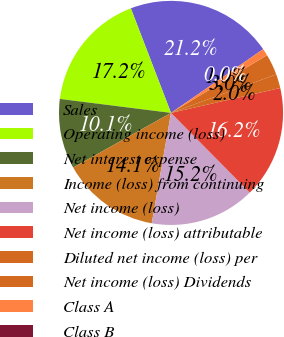<chart> <loc_0><loc_0><loc_500><loc_500><pie_chart><fcel>Sales<fcel>Operating income (loss)<fcel>Net interest expense<fcel>Income (loss) from continuing<fcel>Net income (loss)<fcel>Net income (loss) attributable<fcel>Diluted net income (loss) per<fcel>Net income (loss) Dividends<fcel>Class A<fcel>Class B<nl><fcel>21.21%<fcel>17.17%<fcel>10.1%<fcel>14.14%<fcel>15.15%<fcel>16.16%<fcel>2.02%<fcel>3.03%<fcel>1.01%<fcel>0.0%<nl></chart> 